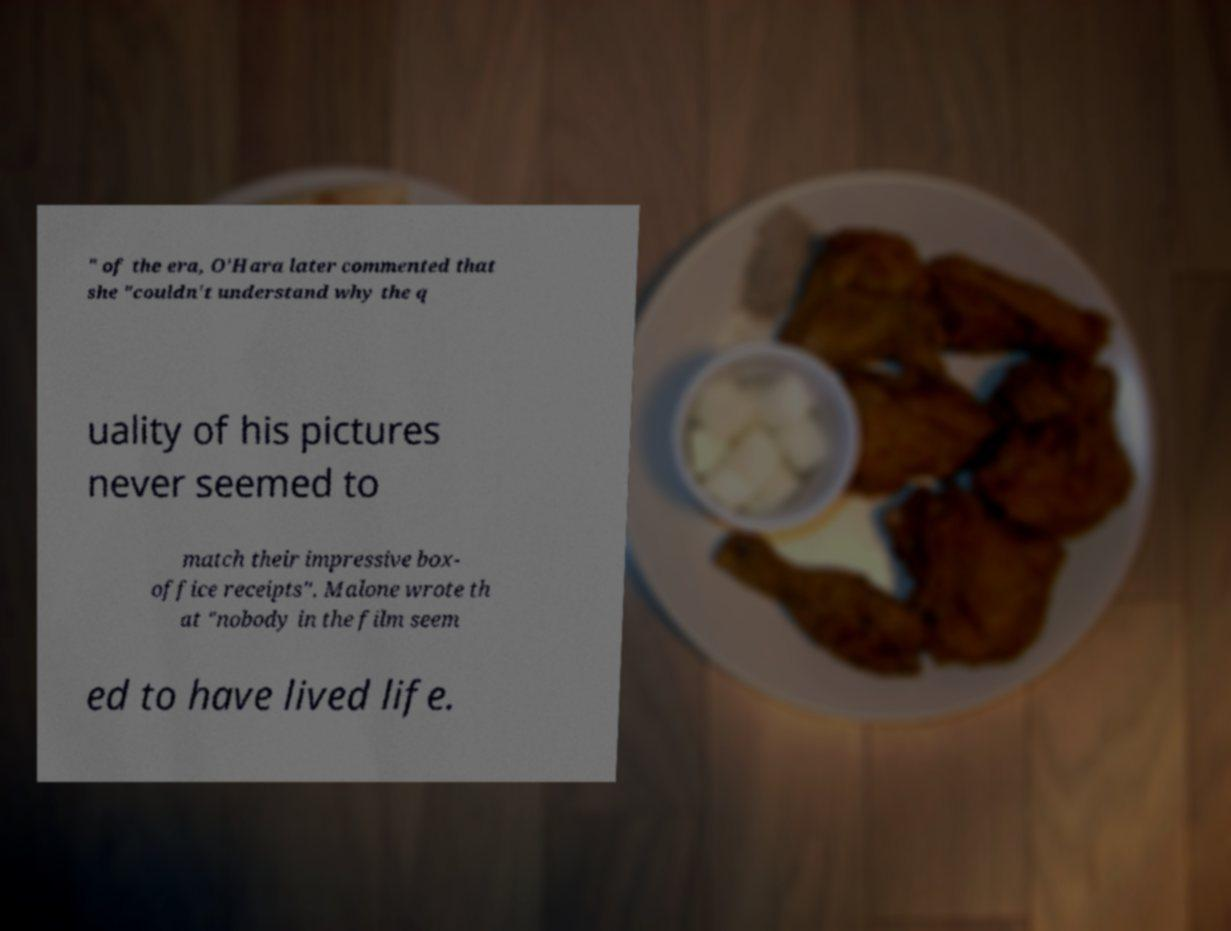Could you extract and type out the text from this image? " of the era, O'Hara later commented that she "couldn't understand why the q uality of his pictures never seemed to match their impressive box- office receipts". Malone wrote th at "nobody in the film seem ed to have lived life. 